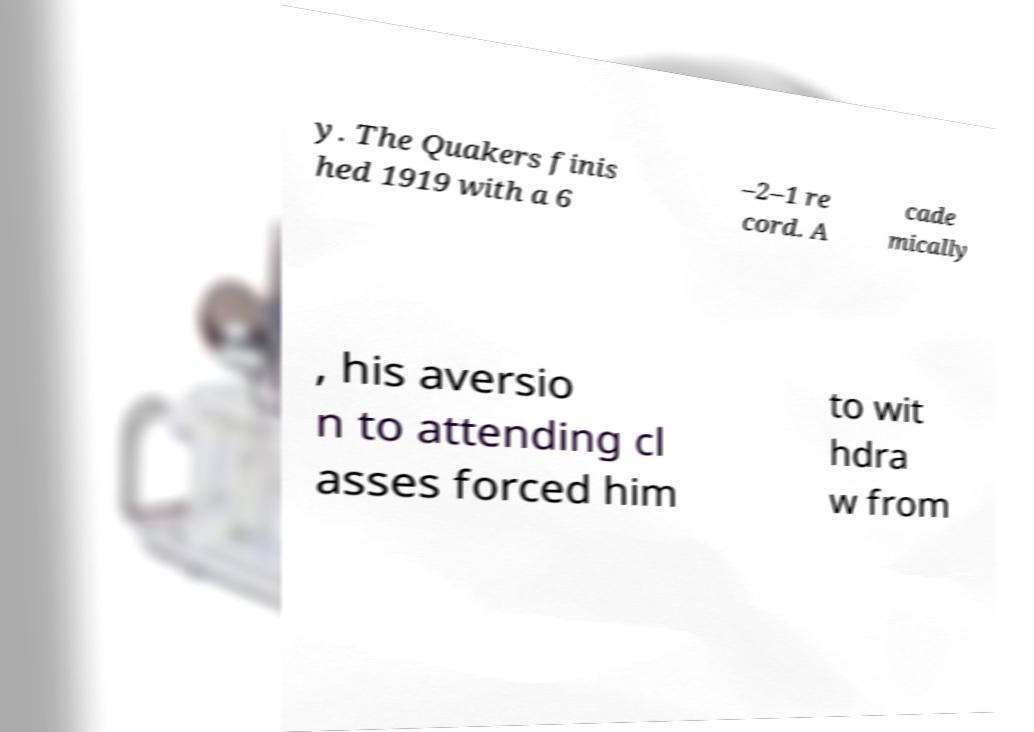What messages or text are displayed in this image? I need them in a readable, typed format. y. The Quakers finis hed 1919 with a 6 –2–1 re cord. A cade mically , his aversio n to attending cl asses forced him to wit hdra w from 